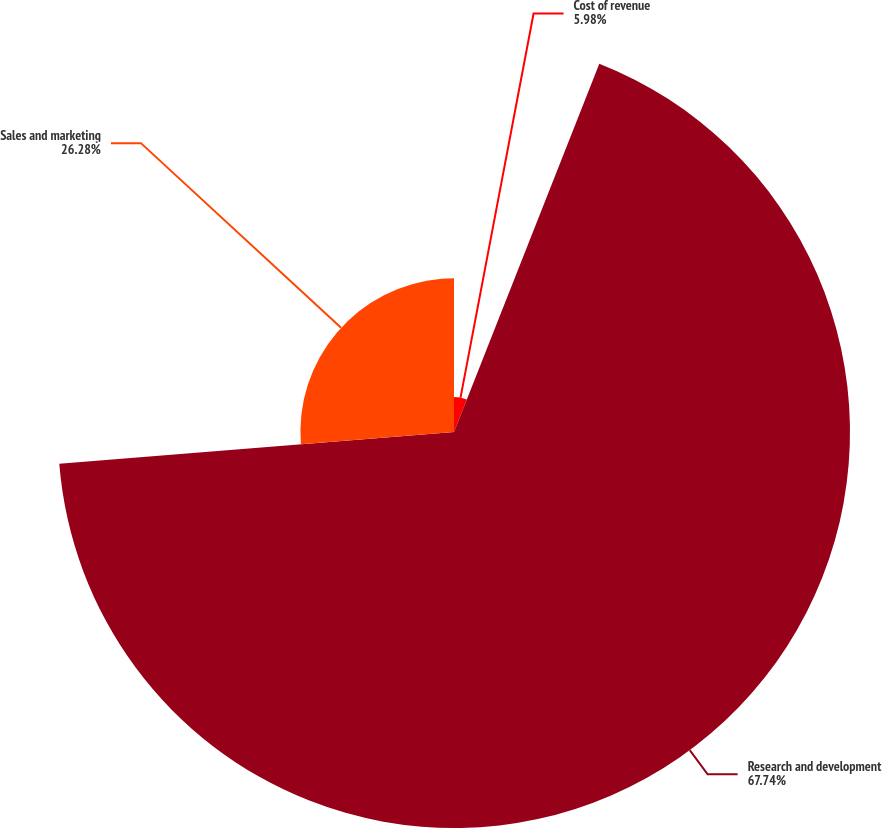Convert chart. <chart><loc_0><loc_0><loc_500><loc_500><pie_chart><fcel>Cost of revenue<fcel>Research and development<fcel>Sales and marketing<nl><fcel>5.98%<fcel>67.74%<fcel>26.28%<nl></chart> 